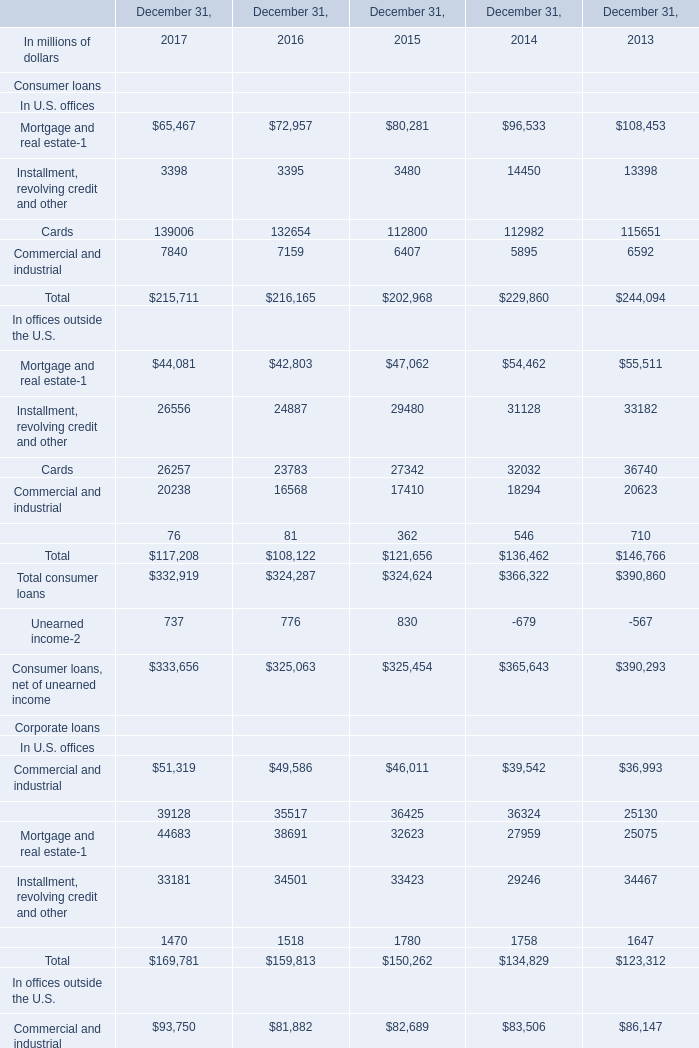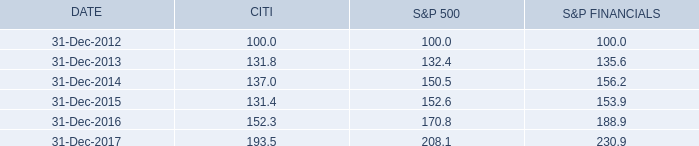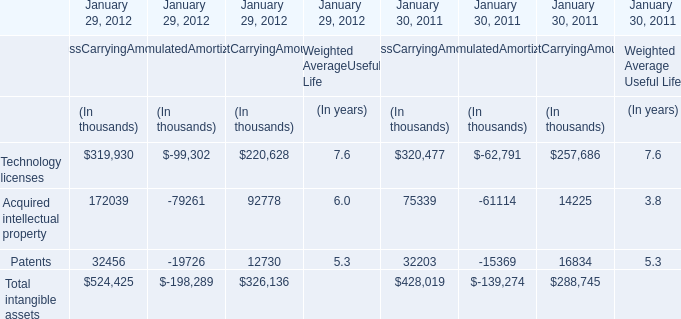What was the total amount of Total in the range of 200000 and 300000 in 2017? (in million) 
Answer: 215711.0. 